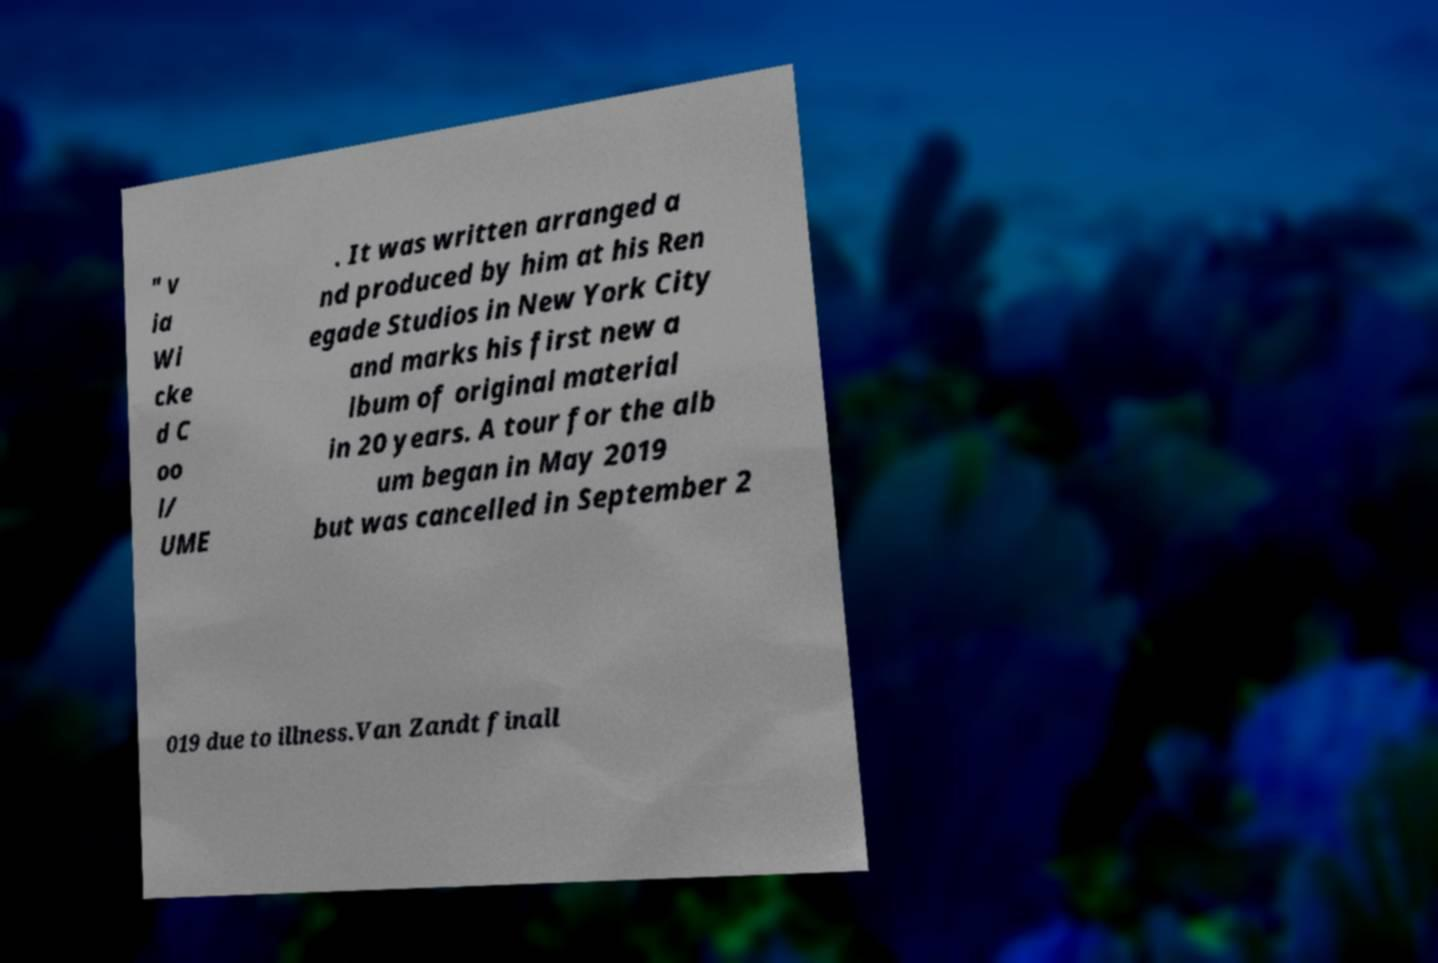Please identify and transcribe the text found in this image. " v ia Wi cke d C oo l/ UME . It was written arranged a nd produced by him at his Ren egade Studios in New York City and marks his first new a lbum of original material in 20 years. A tour for the alb um began in May 2019 but was cancelled in September 2 019 due to illness.Van Zandt finall 